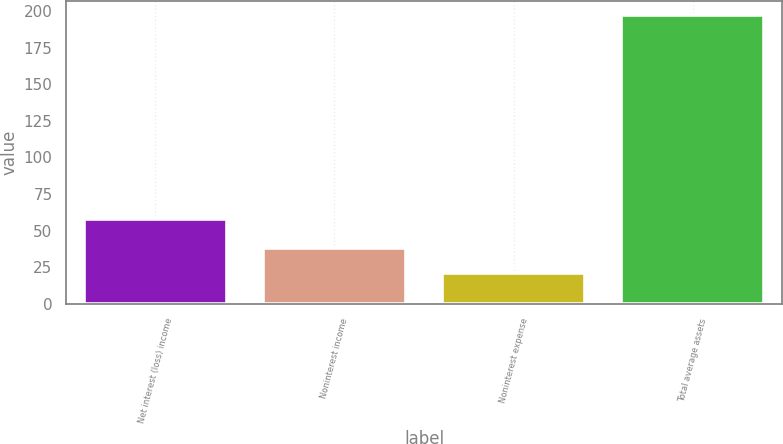<chart> <loc_0><loc_0><loc_500><loc_500><bar_chart><fcel>Net interest (loss) income<fcel>Noninterest income<fcel>Noninterest expense<fcel>Total average assets<nl><fcel>58<fcel>38.45<fcel>20.8<fcel>197.3<nl></chart> 